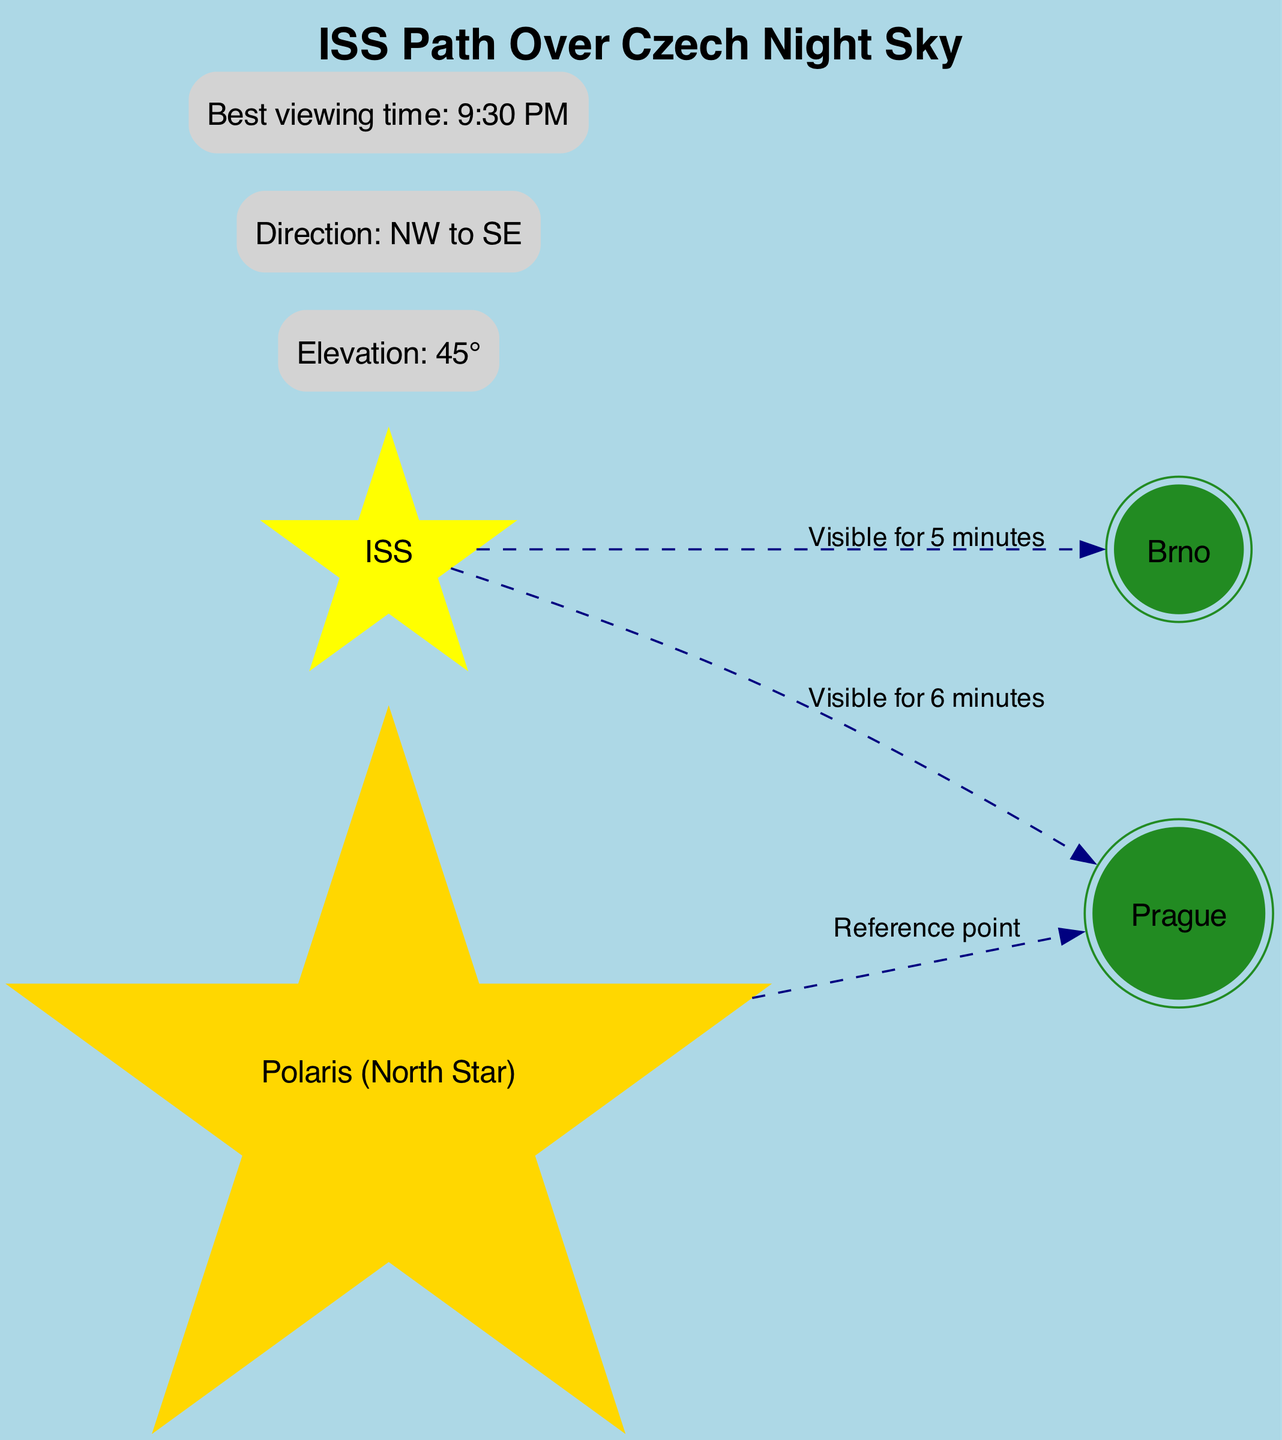What is the shortest visibility time of the ISS from the Czech cities? The visibility time of the ISS from Brno is 5 minutes, which is shorter than the visibility time from Prague, which is 6 minutes. Therefore, the shortest visibility time is from Brno.
Answer: 5 minutes What is the reference point for the diagram? The diagram indicates that Polaris (North Star) serves as the reference point from which the visibility of the ISS is measured to Prague.
Answer: Polaris (North Star) How long is the ISS visible from Prague? According to the diagram, the visibility time from Prague is explicitly mentioned as 6 minutes.
Answer: 6 minutes In which direction does the ISS travel across the Czech sky? The diagram specifies the direction of the ISS's path as NW to SE, indicating the trajectory across the sky.
Answer: NW to SE What is the best viewing time to observe the ISS? The diagram shows that the best viewing time is at 9:30 PM, which is the optimal time to see the ISS.
Answer: 9:30 PM How many cities are depicted in the diagram? The diagram features two cities: Prague and Brno, indicating a total count of cities included.
Answer: 2 What is the elevation angle of the ISS during its visibility? The diagram includes a specific elevation angle for viewing the ISS, which is indicated as 45°.
Answer: 45° Which city has a longer visibility time of the ISS? By comparing the visibility times listed, Prague has 6 minutes and Brno has 5 minutes, making Prague the city with the longer visibility time.
Answer: Prague What type of star is Polaris represented as in the diagram? The diagram shows Polaris categorized as a star, identified by a specific label and represented visually.
Answer: Star 